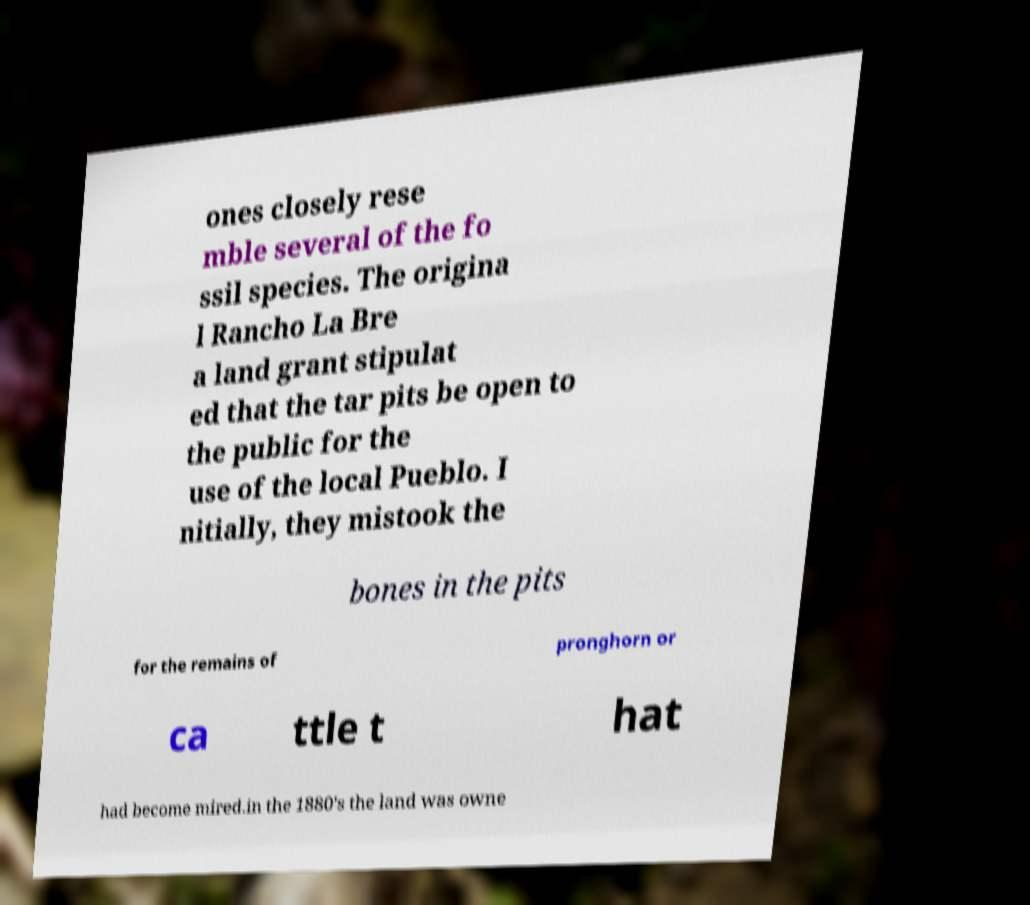Can you read and provide the text displayed in the image?This photo seems to have some interesting text. Can you extract and type it out for me? ones closely rese mble several of the fo ssil species. The origina l Rancho La Bre a land grant stipulat ed that the tar pits be open to the public for the use of the local Pueblo. I nitially, they mistook the bones in the pits for the remains of pronghorn or ca ttle t hat had become mired.in the 1880's the land was owne 